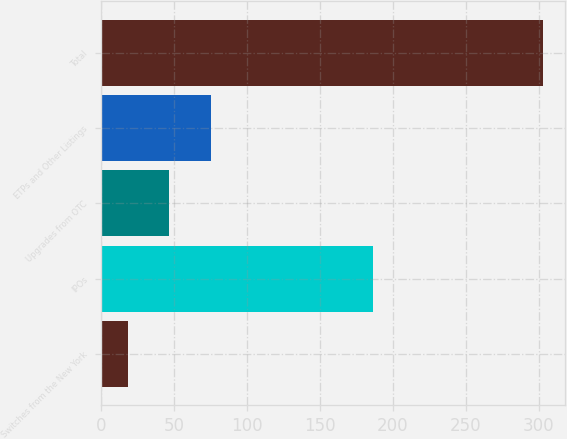<chart> <loc_0><loc_0><loc_500><loc_500><bar_chart><fcel>Switches from the New York<fcel>IPOs<fcel>Upgrades from OTC<fcel>ETPs and Other Listings<fcel>Total<nl><fcel>18<fcel>186<fcel>46.5<fcel>75<fcel>303<nl></chart> 